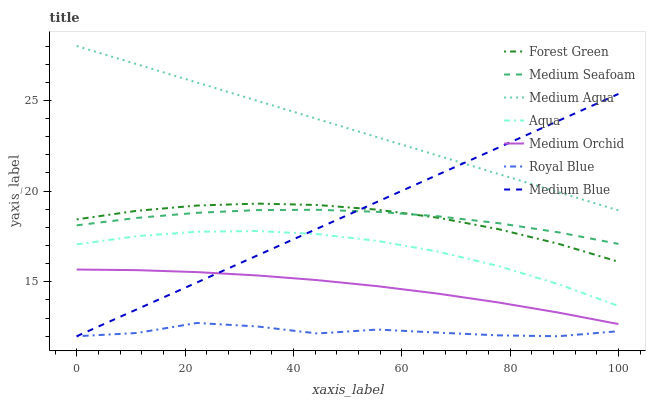Does Royal Blue have the minimum area under the curve?
Answer yes or no. Yes. Does Medium Aqua have the maximum area under the curve?
Answer yes or no. Yes. Does Medium Orchid have the minimum area under the curve?
Answer yes or no. No. Does Medium Orchid have the maximum area under the curve?
Answer yes or no. No. Is Medium Blue the smoothest?
Answer yes or no. Yes. Is Royal Blue the roughest?
Answer yes or no. Yes. Is Medium Orchid the smoothest?
Answer yes or no. No. Is Medium Orchid the roughest?
Answer yes or no. No. Does Medium Blue have the lowest value?
Answer yes or no. Yes. Does Medium Orchid have the lowest value?
Answer yes or no. No. Does Medium Aqua have the highest value?
Answer yes or no. Yes. Does Medium Orchid have the highest value?
Answer yes or no. No. Is Royal Blue less than Forest Green?
Answer yes or no. Yes. Is Forest Green greater than Aqua?
Answer yes or no. Yes. Does Medium Blue intersect Medium Orchid?
Answer yes or no. Yes. Is Medium Blue less than Medium Orchid?
Answer yes or no. No. Is Medium Blue greater than Medium Orchid?
Answer yes or no. No. Does Royal Blue intersect Forest Green?
Answer yes or no. No. 